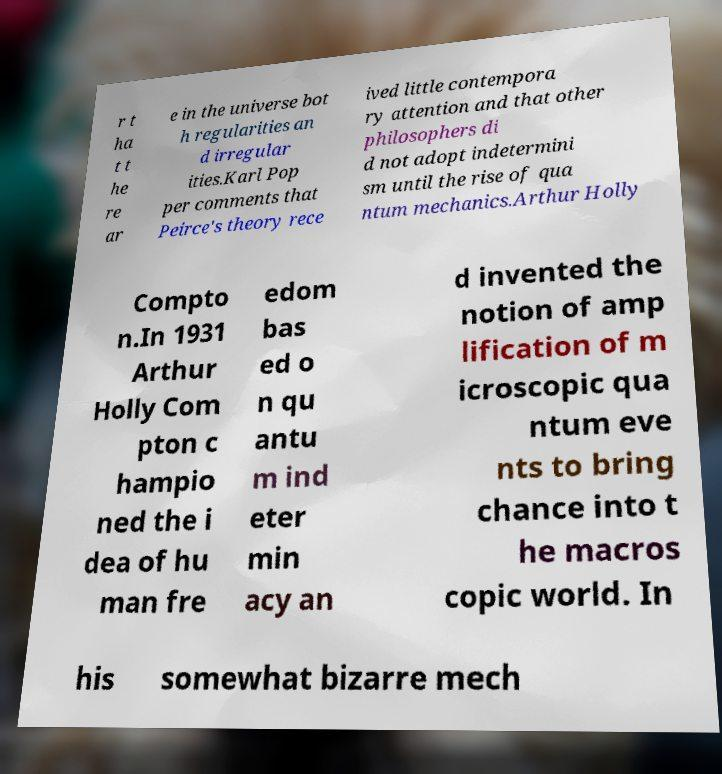What messages or text are displayed in this image? I need them in a readable, typed format. r t ha t t he re ar e in the universe bot h regularities an d irregular ities.Karl Pop per comments that Peirce's theory rece ived little contempora ry attention and that other philosophers di d not adopt indetermini sm until the rise of qua ntum mechanics.Arthur Holly Compto n.In 1931 Arthur Holly Com pton c hampio ned the i dea of hu man fre edom bas ed o n qu antu m ind eter min acy an d invented the notion of amp lification of m icroscopic qua ntum eve nts to bring chance into t he macros copic world. In his somewhat bizarre mech 